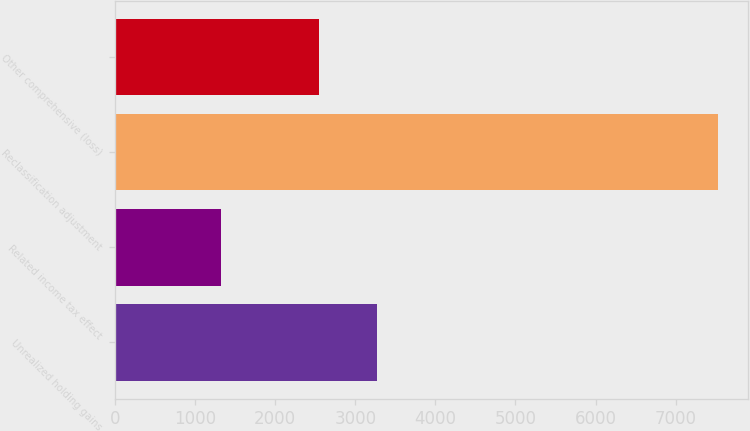Convert chart to OTSL. <chart><loc_0><loc_0><loc_500><loc_500><bar_chart><fcel>Unrealized holding gains<fcel>Related income tax effect<fcel>Reclassification adjustment<fcel>Other comprehensive (loss)<nl><fcel>3272<fcel>1318<fcel>7528<fcel>2541<nl></chart> 